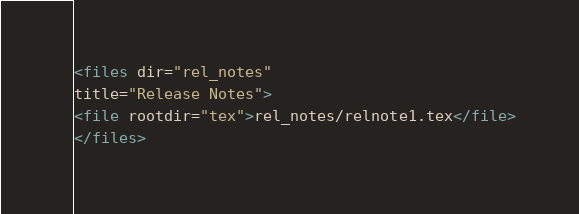Convert code to text. <code><loc_0><loc_0><loc_500><loc_500><_XML_><files dir="rel_notes"
title="Release Notes">
<file rootdir="tex">rel_notes/relnote1.tex</file>
</files>
</code> 